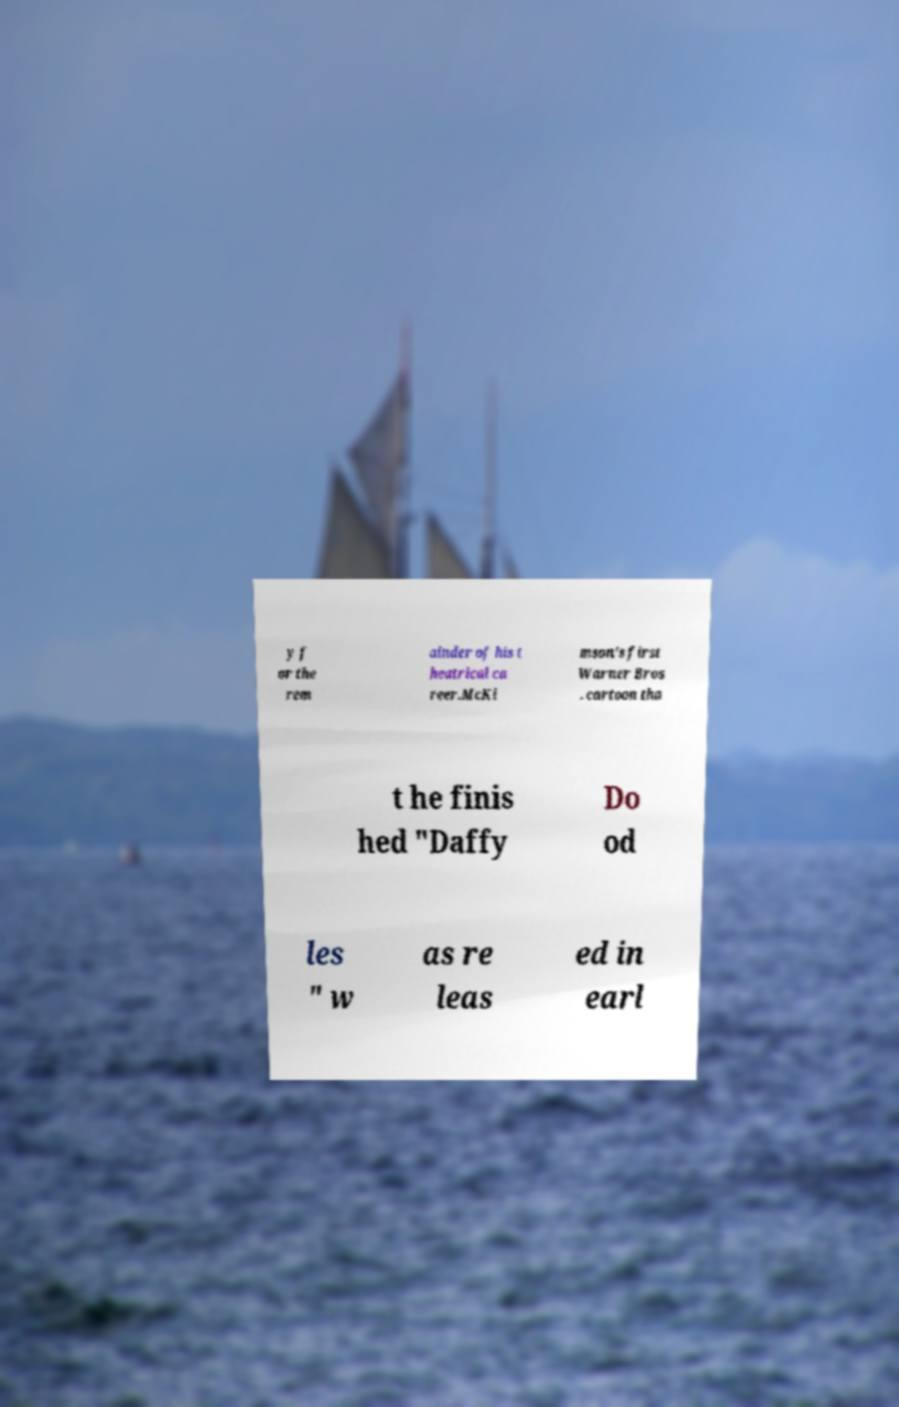Please read and relay the text visible in this image. What does it say? y f or the rem ainder of his t heatrical ca reer.McKi mson's first Warner Bros . cartoon tha t he finis hed "Daffy Do od les " w as re leas ed in earl 